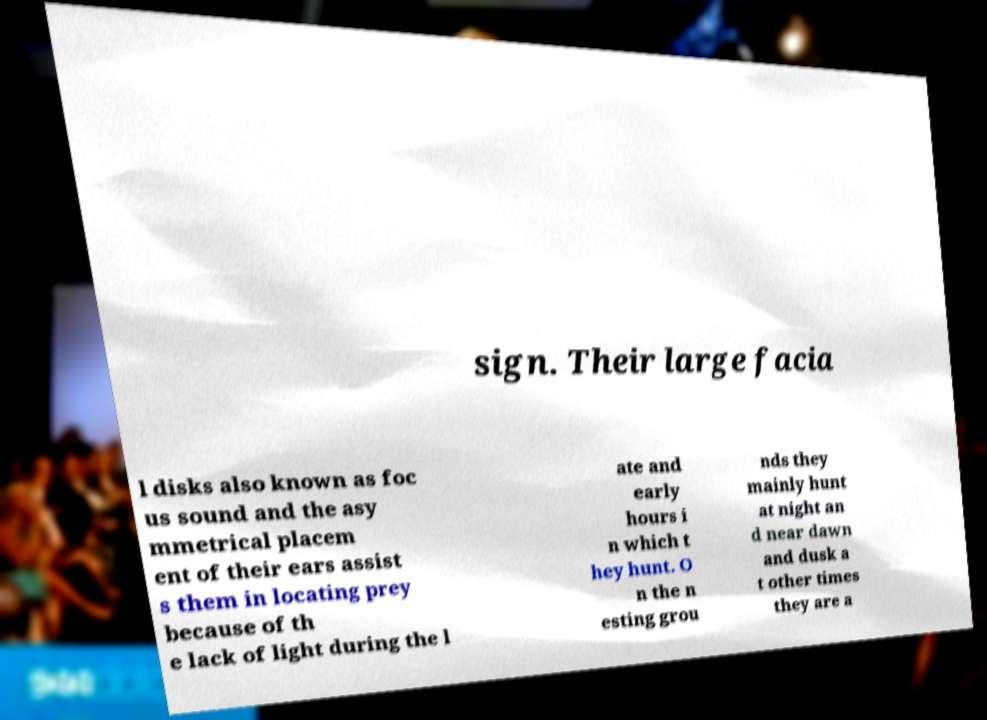Could you assist in decoding the text presented in this image and type it out clearly? sign. Their large facia l disks also known as foc us sound and the asy mmetrical placem ent of their ears assist s them in locating prey because of th e lack of light during the l ate and early hours i n which t hey hunt. O n the n esting grou nds they mainly hunt at night an d near dawn and dusk a t other times they are a 